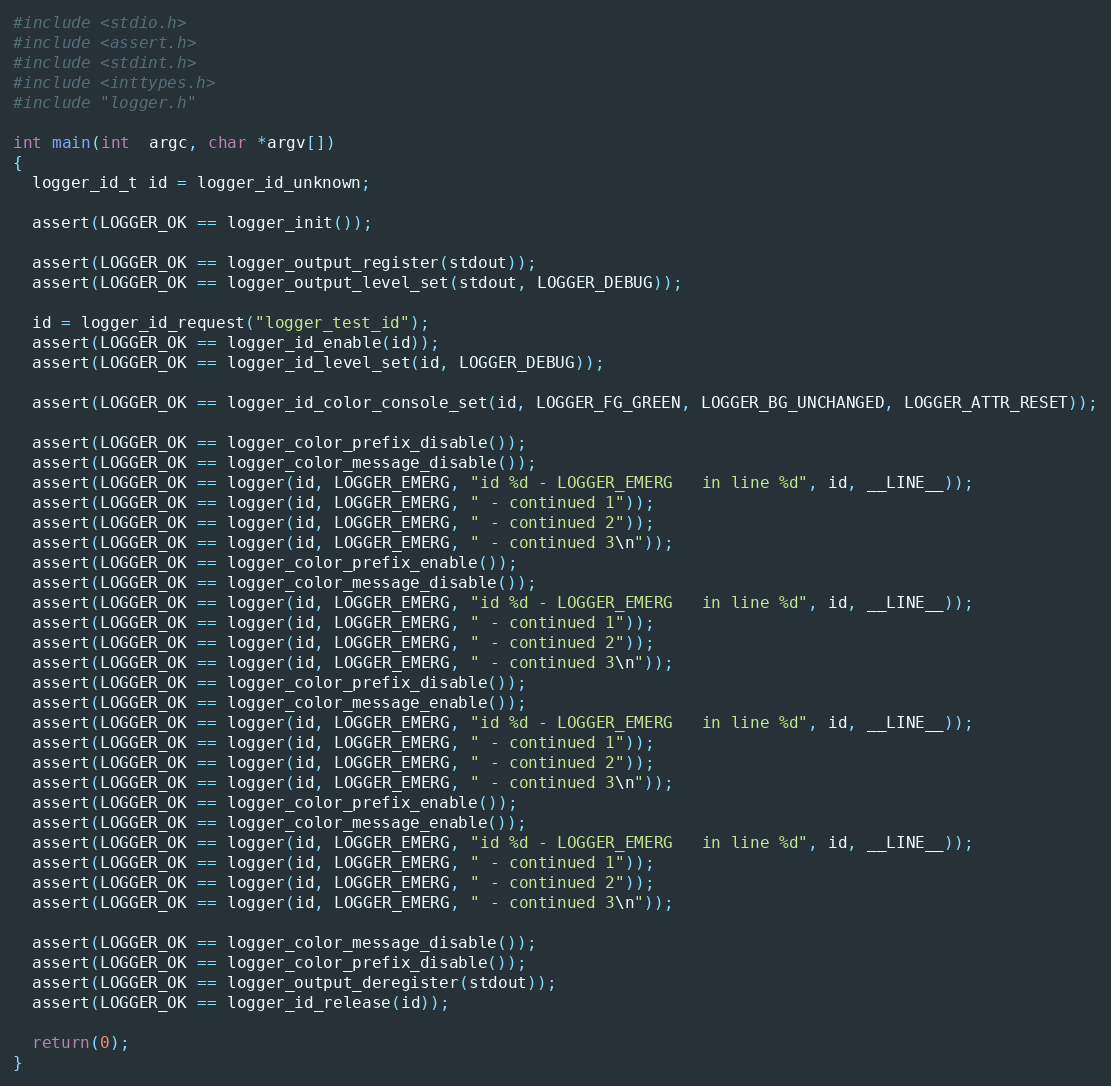<code> <loc_0><loc_0><loc_500><loc_500><_C_>#include <stdio.h>
#include <assert.h>
#include <stdint.h>
#include <inttypes.h>
#include "logger.h"

int main(int  argc, char *argv[])
{
  logger_id_t id = logger_id_unknown;

  assert(LOGGER_OK == logger_init());

  assert(LOGGER_OK == logger_output_register(stdout));
  assert(LOGGER_OK == logger_output_level_set(stdout, LOGGER_DEBUG));

  id = logger_id_request("logger_test_id");
  assert(LOGGER_OK == logger_id_enable(id));
  assert(LOGGER_OK == logger_id_level_set(id, LOGGER_DEBUG));

  assert(LOGGER_OK == logger_id_color_console_set(id, LOGGER_FG_GREEN, LOGGER_BG_UNCHANGED, LOGGER_ATTR_RESET));

  assert(LOGGER_OK == logger_color_prefix_disable());
  assert(LOGGER_OK == logger_color_message_disable());
  assert(LOGGER_OK == logger(id, LOGGER_EMERG, "id %d - LOGGER_EMERG   in line %d", id, __LINE__));
  assert(LOGGER_OK == logger(id, LOGGER_EMERG, " - continued 1"));
  assert(LOGGER_OK == logger(id, LOGGER_EMERG, " - continued 2"));
  assert(LOGGER_OK == logger(id, LOGGER_EMERG, " - continued 3\n"));
  assert(LOGGER_OK == logger_color_prefix_enable());
  assert(LOGGER_OK == logger_color_message_disable());
  assert(LOGGER_OK == logger(id, LOGGER_EMERG, "id %d - LOGGER_EMERG   in line %d", id, __LINE__));
  assert(LOGGER_OK == logger(id, LOGGER_EMERG, " - continued 1"));
  assert(LOGGER_OK == logger(id, LOGGER_EMERG, " - continued 2"));
  assert(LOGGER_OK == logger(id, LOGGER_EMERG, " - continued 3\n"));
  assert(LOGGER_OK == logger_color_prefix_disable());
  assert(LOGGER_OK == logger_color_message_enable());
  assert(LOGGER_OK == logger(id, LOGGER_EMERG, "id %d - LOGGER_EMERG   in line %d", id, __LINE__));
  assert(LOGGER_OK == logger(id, LOGGER_EMERG, " - continued 1"));
  assert(LOGGER_OK == logger(id, LOGGER_EMERG, " - continued 2"));
  assert(LOGGER_OK == logger(id, LOGGER_EMERG, " - continued 3\n"));
  assert(LOGGER_OK == logger_color_prefix_enable());
  assert(LOGGER_OK == logger_color_message_enable());
  assert(LOGGER_OK == logger(id, LOGGER_EMERG, "id %d - LOGGER_EMERG   in line %d", id, __LINE__));
  assert(LOGGER_OK == logger(id, LOGGER_EMERG, " - continued 1"));
  assert(LOGGER_OK == logger(id, LOGGER_EMERG, " - continued 2"));
  assert(LOGGER_OK == logger(id, LOGGER_EMERG, " - continued 3\n"));

  assert(LOGGER_OK == logger_color_message_disable());
  assert(LOGGER_OK == logger_color_prefix_disable());
  assert(LOGGER_OK == logger_output_deregister(stdout));
  assert(LOGGER_OK == logger_id_release(id));

  return(0);
}
</code> 